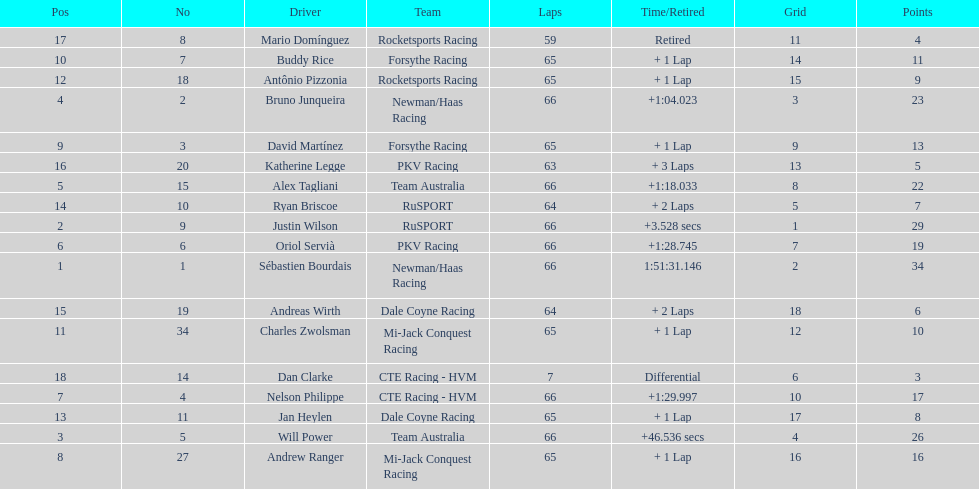How many drivers did not make more than 60 laps? 2. 